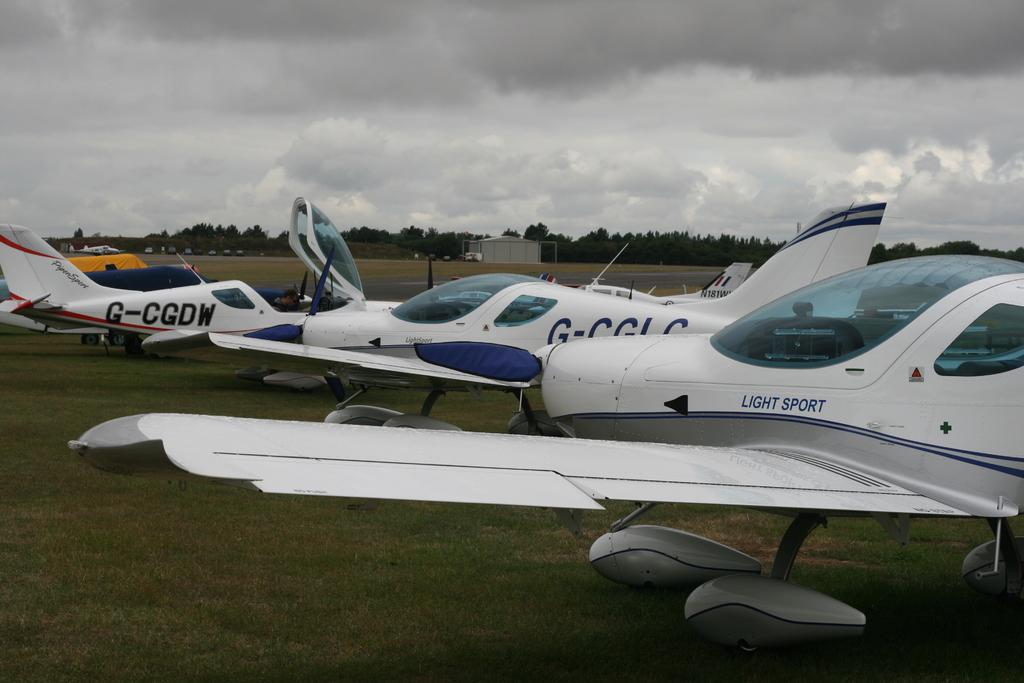What is the main subject of the image? The main subject of the image is planes. What color are the planes in the image? The planes are white in color. Where are the planes located in the image? The planes are on a greenery ground. What can be seen in the background of the image? There are vehicles and trees in the background of the image. How would you describe the sky in the image? The sky is cloudy in the image. How many boats are visible in the image? There are no boats present in the image; it features planes on a greenery ground. What type of hope can be seen in the image? There is no representation of hope in the image; it is a picture of planes on a greenery ground with vehicles and trees in the background. 